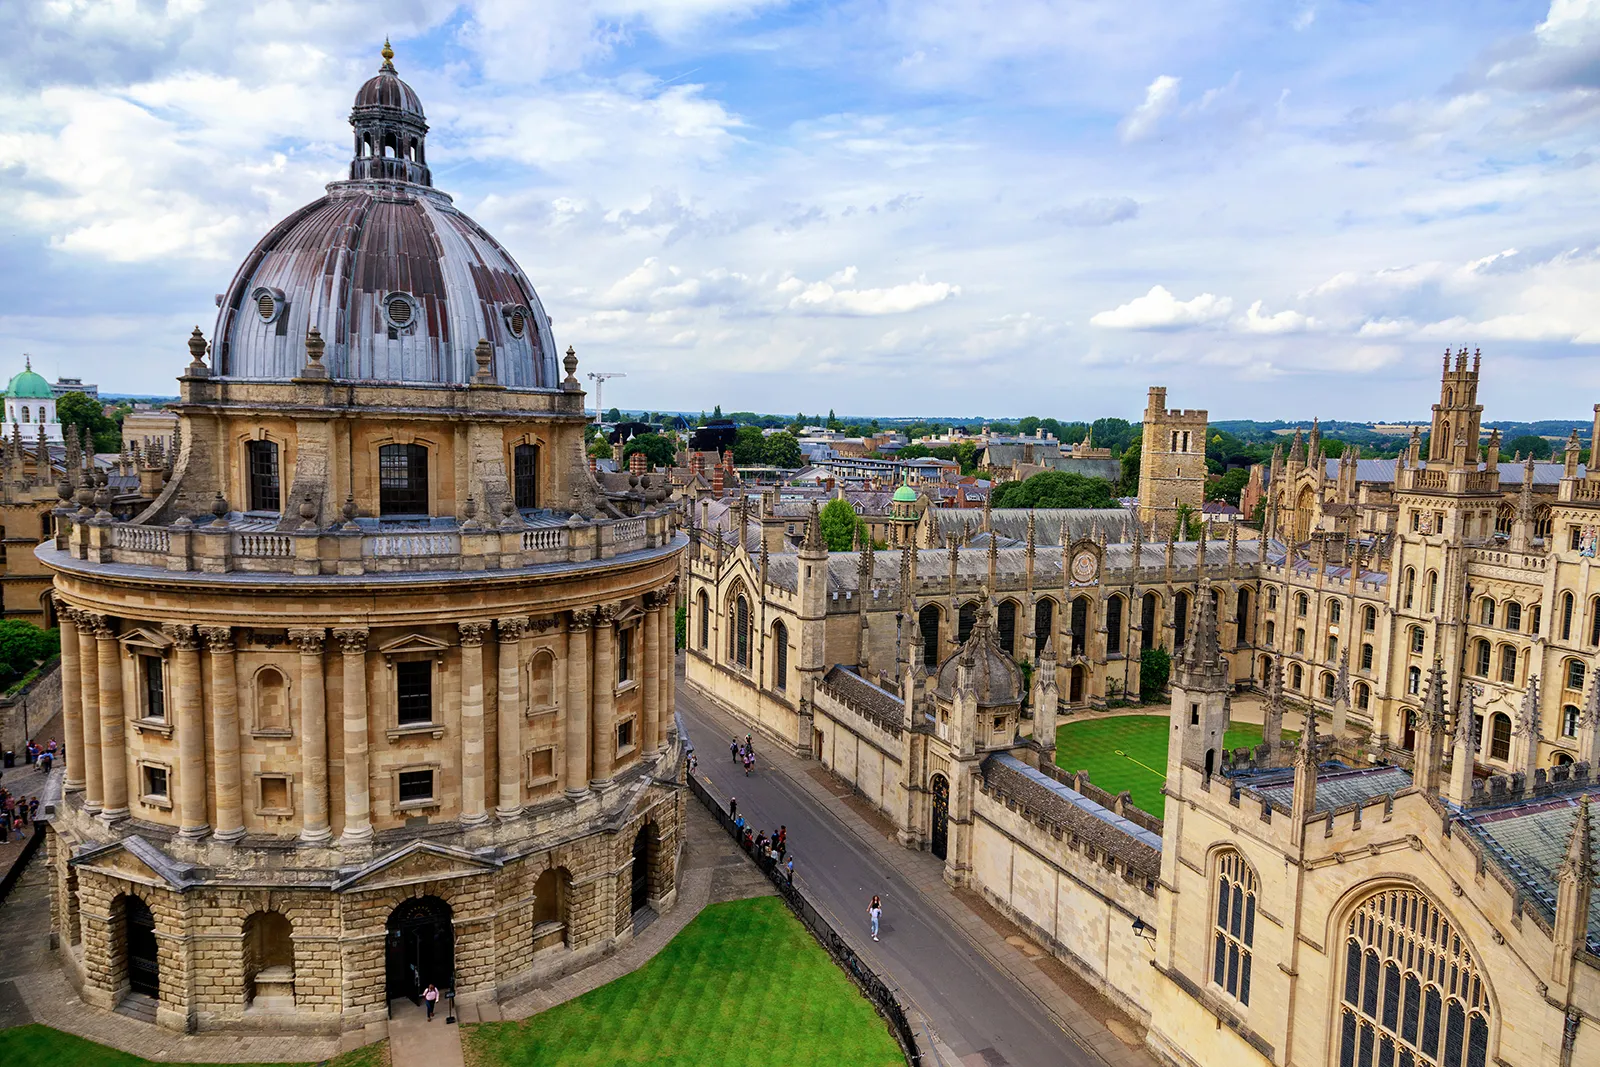What do you think is the significance of this building? The building in the image is the Radcliffe Camera, a monumental library at Oxford University. It holds significant historical and architectural value as it exemplifies the Palladian style of the 18th century. The Radcliffe Camera was constructed between 1737 and 1749 to house the Radcliffe Science Library, funded by the estate of John Radcliffe, a notable physician. Today, it serves as a reading room for the Bodleian Library, symbolizing Oxford's profound academic legacy. 